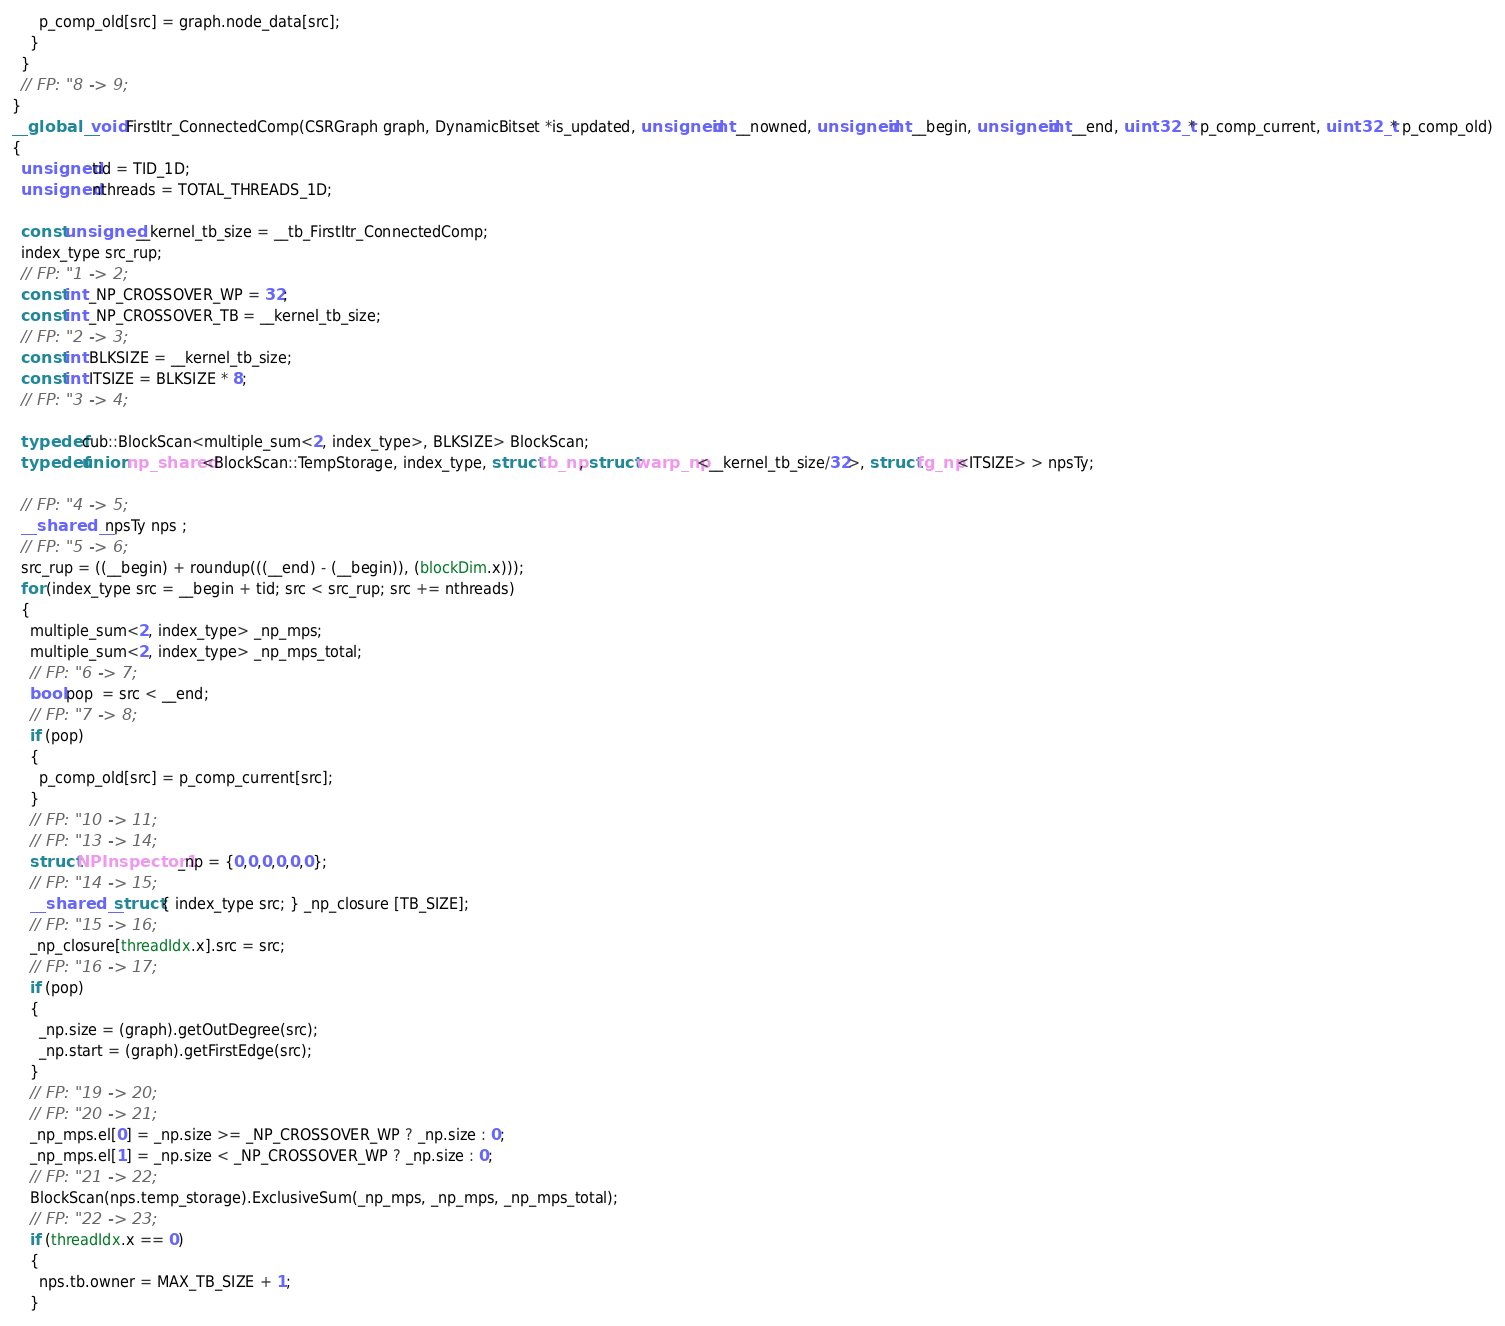Convert code to text. <code><loc_0><loc_0><loc_500><loc_500><_Cuda_>      p_comp_old[src] = graph.node_data[src];
    }
  }
  // FP: "8 -> 9;
}
__global__ void FirstItr_ConnectedComp(CSRGraph graph, DynamicBitset *is_updated, unsigned int __nowned, unsigned int __begin, unsigned int __end, uint32_t * p_comp_current, uint32_t * p_comp_old)
{
  unsigned tid = TID_1D;
  unsigned nthreads = TOTAL_THREADS_1D;

  const unsigned __kernel_tb_size = __tb_FirstItr_ConnectedComp;
  index_type src_rup;
  // FP: "1 -> 2;
  const int _NP_CROSSOVER_WP = 32;
  const int _NP_CROSSOVER_TB = __kernel_tb_size;
  // FP: "2 -> 3;
  const int BLKSIZE = __kernel_tb_size;
  const int ITSIZE = BLKSIZE * 8;
  // FP: "3 -> 4;

  typedef cub::BlockScan<multiple_sum<2, index_type>, BLKSIZE> BlockScan;
  typedef union np_shared<BlockScan::TempStorage, index_type, struct tb_np, struct warp_np<__kernel_tb_size/32>, struct fg_np<ITSIZE> > npsTy;

  // FP: "4 -> 5;
  __shared__ npsTy nps ;
  // FP: "5 -> 6;
  src_rup = ((__begin) + roundup(((__end) - (__begin)), (blockDim.x)));
  for (index_type src = __begin + tid; src < src_rup; src += nthreads)
  {
    multiple_sum<2, index_type> _np_mps;
    multiple_sum<2, index_type> _np_mps_total;
    // FP: "6 -> 7;
    bool pop  = src < __end;
    // FP: "7 -> 8;
    if (pop)
    {
      p_comp_old[src] = p_comp_current[src];
    }
    // FP: "10 -> 11;
    // FP: "13 -> 14;
    struct NPInspector1 _np = {0,0,0,0,0,0};
    // FP: "14 -> 15;
    __shared__ struct { index_type src; } _np_closure [TB_SIZE];
    // FP: "15 -> 16;
    _np_closure[threadIdx.x].src = src;
    // FP: "16 -> 17;
    if (pop)
    {
      _np.size = (graph).getOutDegree(src);
      _np.start = (graph).getFirstEdge(src);
    }
    // FP: "19 -> 20;
    // FP: "20 -> 21;
    _np_mps.el[0] = _np.size >= _NP_CROSSOVER_WP ? _np.size : 0;
    _np_mps.el[1] = _np.size < _NP_CROSSOVER_WP ? _np.size : 0;
    // FP: "21 -> 22;
    BlockScan(nps.temp_storage).ExclusiveSum(_np_mps, _np_mps, _np_mps_total);
    // FP: "22 -> 23;
    if (threadIdx.x == 0)
    {
      nps.tb.owner = MAX_TB_SIZE + 1;
    }</code> 